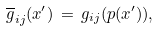<formula> <loc_0><loc_0><loc_500><loc_500>\overline { g } _ { i j } ( x ^ { \prime } ) \, = \, g _ { i j } ( p ( x ^ { \prime } ) ) ,</formula> 